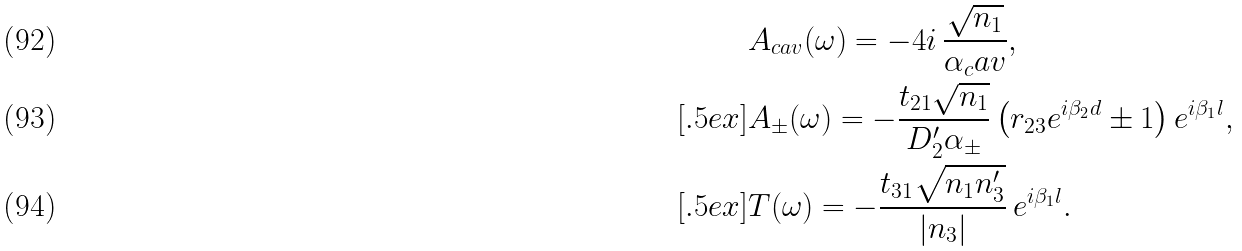Convert formula to latex. <formula><loc_0><loc_0><loc_500><loc_500>& A _ { c a v } ( \omega ) = - 4 i \, \frac { \sqrt { n _ { 1 } } } { \alpha _ { c } a v } , \\ [ . 5 e x ] & A _ { \pm } ( \omega ) = - \frac { t _ { 2 1 } \sqrt { n _ { 1 } } } { D _ { 2 } ^ { \prime } \alpha _ { \pm } } \left ( r _ { 2 3 } e ^ { i \beta _ { 2 } d } \pm 1 \right ) e ^ { i \beta _ { 1 } l } , \\ [ . 5 e x ] & T ( \omega ) = - \frac { t _ { 3 1 } \sqrt { n _ { 1 } n _ { 3 } ^ { \prime } } } { | n _ { 3 } | } \, e ^ { i \beta _ { 1 } l } .</formula> 